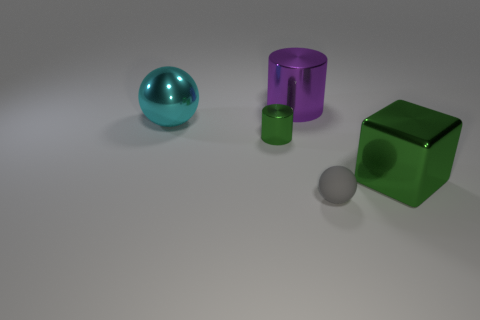Subtract all purple cylinders. How many cylinders are left? 1 Subtract 1 blocks. How many blocks are left? 0 Subtract all blocks. How many objects are left? 4 Add 5 large cyan spheres. How many objects exist? 10 Add 1 tiny cyan metal spheres. How many tiny cyan metal spheres exist? 1 Subtract 1 green blocks. How many objects are left? 4 Subtract all red cubes. Subtract all green balls. How many cubes are left? 1 Subtract all red cylinders. How many yellow blocks are left? 0 Subtract all large green matte cylinders. Subtract all big purple shiny cylinders. How many objects are left? 4 Add 4 metallic objects. How many metallic objects are left? 8 